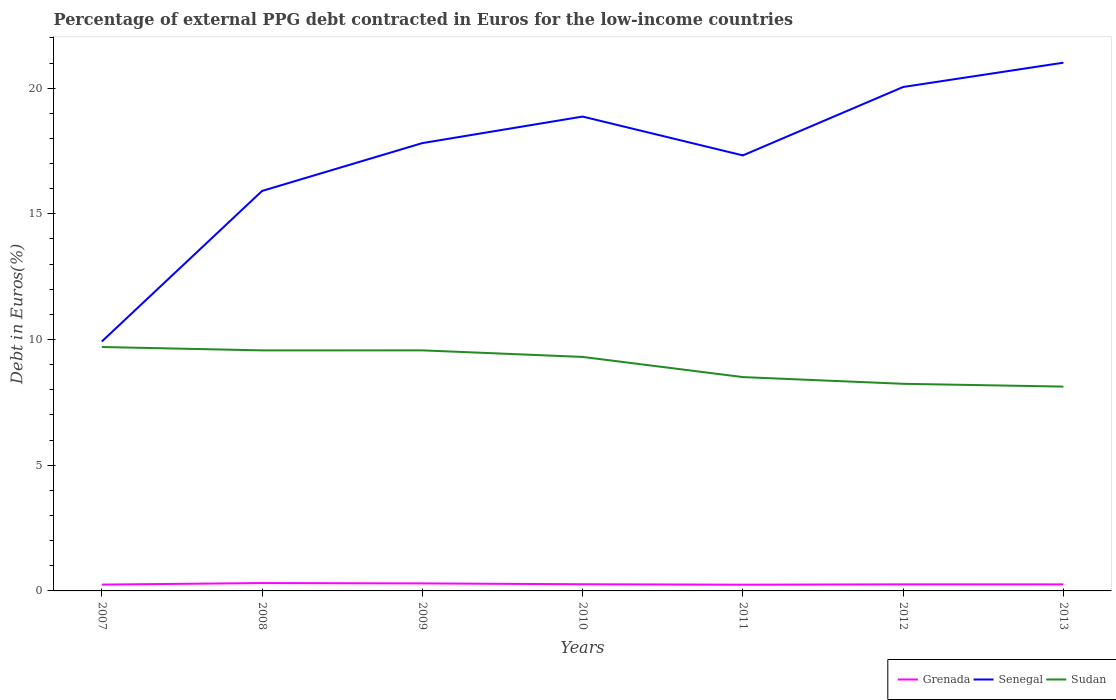Is the number of lines equal to the number of legend labels?
Your answer should be compact. Yes. Across all years, what is the maximum percentage of external PPG debt contracted in Euros in Sudan?
Give a very brief answer. 8.13. In which year was the percentage of external PPG debt contracted in Euros in Senegal maximum?
Give a very brief answer. 2007. What is the total percentage of external PPG debt contracted in Euros in Senegal in the graph?
Provide a succinct answer. -7.4. What is the difference between the highest and the second highest percentage of external PPG debt contracted in Euros in Grenada?
Give a very brief answer. 0.07. What is the difference between the highest and the lowest percentage of external PPG debt contracted in Euros in Senegal?
Provide a short and direct response. 5. How many years are there in the graph?
Your response must be concise. 7. Does the graph contain any zero values?
Make the answer very short. No. How many legend labels are there?
Offer a very short reply. 3. What is the title of the graph?
Make the answer very short. Percentage of external PPG debt contracted in Euros for the low-income countries. Does "Aruba" appear as one of the legend labels in the graph?
Ensure brevity in your answer.  No. What is the label or title of the Y-axis?
Make the answer very short. Debt in Euros(%). What is the Debt in Euros(%) in Grenada in 2007?
Your response must be concise. 0.25. What is the Debt in Euros(%) of Senegal in 2007?
Make the answer very short. 9.92. What is the Debt in Euros(%) of Sudan in 2007?
Your response must be concise. 9.7. What is the Debt in Euros(%) of Grenada in 2008?
Your answer should be compact. 0.31. What is the Debt in Euros(%) of Senegal in 2008?
Your response must be concise. 15.91. What is the Debt in Euros(%) in Sudan in 2008?
Offer a terse response. 9.57. What is the Debt in Euros(%) in Grenada in 2009?
Your response must be concise. 0.3. What is the Debt in Euros(%) of Senegal in 2009?
Offer a very short reply. 17.81. What is the Debt in Euros(%) of Sudan in 2009?
Make the answer very short. 9.57. What is the Debt in Euros(%) in Grenada in 2010?
Provide a short and direct response. 0.27. What is the Debt in Euros(%) in Senegal in 2010?
Keep it short and to the point. 18.87. What is the Debt in Euros(%) in Sudan in 2010?
Give a very brief answer. 9.31. What is the Debt in Euros(%) of Grenada in 2011?
Keep it short and to the point. 0.25. What is the Debt in Euros(%) in Senegal in 2011?
Ensure brevity in your answer.  17.32. What is the Debt in Euros(%) of Sudan in 2011?
Give a very brief answer. 8.51. What is the Debt in Euros(%) in Grenada in 2012?
Your answer should be very brief. 0.26. What is the Debt in Euros(%) of Senegal in 2012?
Keep it short and to the point. 20.05. What is the Debt in Euros(%) in Sudan in 2012?
Offer a very short reply. 8.24. What is the Debt in Euros(%) in Grenada in 2013?
Your answer should be compact. 0.26. What is the Debt in Euros(%) in Senegal in 2013?
Your response must be concise. 21.01. What is the Debt in Euros(%) of Sudan in 2013?
Make the answer very short. 8.13. Across all years, what is the maximum Debt in Euros(%) of Grenada?
Make the answer very short. 0.31. Across all years, what is the maximum Debt in Euros(%) in Senegal?
Give a very brief answer. 21.01. Across all years, what is the maximum Debt in Euros(%) of Sudan?
Offer a very short reply. 9.7. Across all years, what is the minimum Debt in Euros(%) of Grenada?
Your response must be concise. 0.25. Across all years, what is the minimum Debt in Euros(%) in Senegal?
Your answer should be very brief. 9.92. Across all years, what is the minimum Debt in Euros(%) in Sudan?
Keep it short and to the point. 8.13. What is the total Debt in Euros(%) in Grenada in the graph?
Offer a terse response. 1.9. What is the total Debt in Euros(%) in Senegal in the graph?
Provide a succinct answer. 120.9. What is the total Debt in Euros(%) in Sudan in the graph?
Your answer should be compact. 63.02. What is the difference between the Debt in Euros(%) of Grenada in 2007 and that in 2008?
Provide a short and direct response. -0.06. What is the difference between the Debt in Euros(%) of Senegal in 2007 and that in 2008?
Your response must be concise. -5.99. What is the difference between the Debt in Euros(%) of Sudan in 2007 and that in 2008?
Offer a very short reply. 0.13. What is the difference between the Debt in Euros(%) of Grenada in 2007 and that in 2009?
Provide a succinct answer. -0.05. What is the difference between the Debt in Euros(%) of Senegal in 2007 and that in 2009?
Ensure brevity in your answer.  -7.89. What is the difference between the Debt in Euros(%) of Sudan in 2007 and that in 2009?
Keep it short and to the point. 0.13. What is the difference between the Debt in Euros(%) of Grenada in 2007 and that in 2010?
Offer a terse response. -0.01. What is the difference between the Debt in Euros(%) of Senegal in 2007 and that in 2010?
Your answer should be very brief. -8.95. What is the difference between the Debt in Euros(%) of Sudan in 2007 and that in 2010?
Your answer should be compact. 0.39. What is the difference between the Debt in Euros(%) in Grenada in 2007 and that in 2011?
Your answer should be very brief. 0. What is the difference between the Debt in Euros(%) of Senegal in 2007 and that in 2011?
Your answer should be compact. -7.4. What is the difference between the Debt in Euros(%) of Sudan in 2007 and that in 2011?
Offer a terse response. 1.2. What is the difference between the Debt in Euros(%) of Grenada in 2007 and that in 2012?
Offer a terse response. -0.01. What is the difference between the Debt in Euros(%) in Senegal in 2007 and that in 2012?
Your response must be concise. -10.13. What is the difference between the Debt in Euros(%) of Sudan in 2007 and that in 2012?
Your answer should be compact. 1.46. What is the difference between the Debt in Euros(%) of Grenada in 2007 and that in 2013?
Your answer should be compact. -0.01. What is the difference between the Debt in Euros(%) in Senegal in 2007 and that in 2013?
Your answer should be very brief. -11.09. What is the difference between the Debt in Euros(%) in Sudan in 2007 and that in 2013?
Offer a very short reply. 1.58. What is the difference between the Debt in Euros(%) in Grenada in 2008 and that in 2009?
Offer a terse response. 0.01. What is the difference between the Debt in Euros(%) of Senegal in 2008 and that in 2009?
Keep it short and to the point. -1.9. What is the difference between the Debt in Euros(%) in Sudan in 2008 and that in 2009?
Provide a short and direct response. -0. What is the difference between the Debt in Euros(%) of Grenada in 2008 and that in 2010?
Provide a succinct answer. 0.05. What is the difference between the Debt in Euros(%) in Senegal in 2008 and that in 2010?
Offer a very short reply. -2.96. What is the difference between the Debt in Euros(%) in Sudan in 2008 and that in 2010?
Offer a very short reply. 0.26. What is the difference between the Debt in Euros(%) of Grenada in 2008 and that in 2011?
Your response must be concise. 0.07. What is the difference between the Debt in Euros(%) in Senegal in 2008 and that in 2011?
Offer a terse response. -1.41. What is the difference between the Debt in Euros(%) in Sudan in 2008 and that in 2011?
Your answer should be compact. 1.06. What is the difference between the Debt in Euros(%) of Grenada in 2008 and that in 2012?
Your answer should be very brief. 0.05. What is the difference between the Debt in Euros(%) in Senegal in 2008 and that in 2012?
Give a very brief answer. -4.14. What is the difference between the Debt in Euros(%) in Sudan in 2008 and that in 2012?
Ensure brevity in your answer.  1.33. What is the difference between the Debt in Euros(%) in Grenada in 2008 and that in 2013?
Provide a short and direct response. 0.05. What is the difference between the Debt in Euros(%) in Senegal in 2008 and that in 2013?
Give a very brief answer. -5.1. What is the difference between the Debt in Euros(%) of Sudan in 2008 and that in 2013?
Keep it short and to the point. 1.44. What is the difference between the Debt in Euros(%) in Grenada in 2009 and that in 2010?
Give a very brief answer. 0.03. What is the difference between the Debt in Euros(%) of Senegal in 2009 and that in 2010?
Keep it short and to the point. -1.06. What is the difference between the Debt in Euros(%) in Sudan in 2009 and that in 2010?
Provide a short and direct response. 0.26. What is the difference between the Debt in Euros(%) in Grenada in 2009 and that in 2011?
Ensure brevity in your answer.  0.05. What is the difference between the Debt in Euros(%) of Senegal in 2009 and that in 2011?
Offer a terse response. 0.49. What is the difference between the Debt in Euros(%) in Sudan in 2009 and that in 2011?
Provide a succinct answer. 1.06. What is the difference between the Debt in Euros(%) in Grenada in 2009 and that in 2012?
Make the answer very short. 0.04. What is the difference between the Debt in Euros(%) of Senegal in 2009 and that in 2012?
Your response must be concise. -2.23. What is the difference between the Debt in Euros(%) in Sudan in 2009 and that in 2012?
Make the answer very short. 1.33. What is the difference between the Debt in Euros(%) of Grenada in 2009 and that in 2013?
Provide a short and direct response. 0.04. What is the difference between the Debt in Euros(%) of Senegal in 2009 and that in 2013?
Your response must be concise. -3.2. What is the difference between the Debt in Euros(%) of Sudan in 2009 and that in 2013?
Make the answer very short. 1.44. What is the difference between the Debt in Euros(%) of Grenada in 2010 and that in 2011?
Your answer should be compact. 0.02. What is the difference between the Debt in Euros(%) of Senegal in 2010 and that in 2011?
Your response must be concise. 1.55. What is the difference between the Debt in Euros(%) in Sudan in 2010 and that in 2011?
Offer a terse response. 0.8. What is the difference between the Debt in Euros(%) in Grenada in 2010 and that in 2012?
Offer a very short reply. 0. What is the difference between the Debt in Euros(%) in Senegal in 2010 and that in 2012?
Make the answer very short. -1.18. What is the difference between the Debt in Euros(%) of Sudan in 2010 and that in 2012?
Make the answer very short. 1.07. What is the difference between the Debt in Euros(%) in Grenada in 2010 and that in 2013?
Ensure brevity in your answer.  0.01. What is the difference between the Debt in Euros(%) of Senegal in 2010 and that in 2013?
Your response must be concise. -2.14. What is the difference between the Debt in Euros(%) in Sudan in 2010 and that in 2013?
Provide a succinct answer. 1.18. What is the difference between the Debt in Euros(%) of Grenada in 2011 and that in 2012?
Provide a succinct answer. -0.01. What is the difference between the Debt in Euros(%) of Senegal in 2011 and that in 2012?
Offer a very short reply. -2.72. What is the difference between the Debt in Euros(%) in Sudan in 2011 and that in 2012?
Your answer should be very brief. 0.27. What is the difference between the Debt in Euros(%) in Grenada in 2011 and that in 2013?
Make the answer very short. -0.01. What is the difference between the Debt in Euros(%) of Senegal in 2011 and that in 2013?
Ensure brevity in your answer.  -3.69. What is the difference between the Debt in Euros(%) of Sudan in 2011 and that in 2013?
Keep it short and to the point. 0.38. What is the difference between the Debt in Euros(%) in Grenada in 2012 and that in 2013?
Your response must be concise. 0. What is the difference between the Debt in Euros(%) of Senegal in 2012 and that in 2013?
Keep it short and to the point. -0.97. What is the difference between the Debt in Euros(%) of Sudan in 2012 and that in 2013?
Offer a very short reply. 0.11. What is the difference between the Debt in Euros(%) of Grenada in 2007 and the Debt in Euros(%) of Senegal in 2008?
Your response must be concise. -15.66. What is the difference between the Debt in Euros(%) of Grenada in 2007 and the Debt in Euros(%) of Sudan in 2008?
Keep it short and to the point. -9.32. What is the difference between the Debt in Euros(%) in Senegal in 2007 and the Debt in Euros(%) in Sudan in 2008?
Provide a succinct answer. 0.35. What is the difference between the Debt in Euros(%) of Grenada in 2007 and the Debt in Euros(%) of Senegal in 2009?
Make the answer very short. -17.56. What is the difference between the Debt in Euros(%) of Grenada in 2007 and the Debt in Euros(%) of Sudan in 2009?
Give a very brief answer. -9.32. What is the difference between the Debt in Euros(%) of Senegal in 2007 and the Debt in Euros(%) of Sudan in 2009?
Your response must be concise. 0.35. What is the difference between the Debt in Euros(%) of Grenada in 2007 and the Debt in Euros(%) of Senegal in 2010?
Offer a terse response. -18.62. What is the difference between the Debt in Euros(%) in Grenada in 2007 and the Debt in Euros(%) in Sudan in 2010?
Ensure brevity in your answer.  -9.06. What is the difference between the Debt in Euros(%) of Senegal in 2007 and the Debt in Euros(%) of Sudan in 2010?
Your answer should be compact. 0.61. What is the difference between the Debt in Euros(%) of Grenada in 2007 and the Debt in Euros(%) of Senegal in 2011?
Ensure brevity in your answer.  -17.07. What is the difference between the Debt in Euros(%) in Grenada in 2007 and the Debt in Euros(%) in Sudan in 2011?
Your answer should be very brief. -8.25. What is the difference between the Debt in Euros(%) of Senegal in 2007 and the Debt in Euros(%) of Sudan in 2011?
Offer a very short reply. 1.41. What is the difference between the Debt in Euros(%) of Grenada in 2007 and the Debt in Euros(%) of Senegal in 2012?
Your response must be concise. -19.79. What is the difference between the Debt in Euros(%) of Grenada in 2007 and the Debt in Euros(%) of Sudan in 2012?
Keep it short and to the point. -7.99. What is the difference between the Debt in Euros(%) of Senegal in 2007 and the Debt in Euros(%) of Sudan in 2012?
Your response must be concise. 1.68. What is the difference between the Debt in Euros(%) of Grenada in 2007 and the Debt in Euros(%) of Senegal in 2013?
Offer a terse response. -20.76. What is the difference between the Debt in Euros(%) of Grenada in 2007 and the Debt in Euros(%) of Sudan in 2013?
Offer a very short reply. -7.88. What is the difference between the Debt in Euros(%) of Senegal in 2007 and the Debt in Euros(%) of Sudan in 2013?
Give a very brief answer. 1.79. What is the difference between the Debt in Euros(%) in Grenada in 2008 and the Debt in Euros(%) in Senegal in 2009?
Make the answer very short. -17.5. What is the difference between the Debt in Euros(%) of Grenada in 2008 and the Debt in Euros(%) of Sudan in 2009?
Make the answer very short. -9.26. What is the difference between the Debt in Euros(%) in Senegal in 2008 and the Debt in Euros(%) in Sudan in 2009?
Provide a succinct answer. 6.34. What is the difference between the Debt in Euros(%) of Grenada in 2008 and the Debt in Euros(%) of Senegal in 2010?
Your response must be concise. -18.56. What is the difference between the Debt in Euros(%) in Grenada in 2008 and the Debt in Euros(%) in Sudan in 2010?
Make the answer very short. -9. What is the difference between the Debt in Euros(%) of Senegal in 2008 and the Debt in Euros(%) of Sudan in 2010?
Your answer should be very brief. 6.6. What is the difference between the Debt in Euros(%) of Grenada in 2008 and the Debt in Euros(%) of Senegal in 2011?
Your response must be concise. -17.01. What is the difference between the Debt in Euros(%) in Grenada in 2008 and the Debt in Euros(%) in Sudan in 2011?
Ensure brevity in your answer.  -8.19. What is the difference between the Debt in Euros(%) in Senegal in 2008 and the Debt in Euros(%) in Sudan in 2011?
Provide a short and direct response. 7.4. What is the difference between the Debt in Euros(%) in Grenada in 2008 and the Debt in Euros(%) in Senegal in 2012?
Offer a very short reply. -19.73. What is the difference between the Debt in Euros(%) in Grenada in 2008 and the Debt in Euros(%) in Sudan in 2012?
Your answer should be compact. -7.93. What is the difference between the Debt in Euros(%) in Senegal in 2008 and the Debt in Euros(%) in Sudan in 2012?
Give a very brief answer. 7.67. What is the difference between the Debt in Euros(%) in Grenada in 2008 and the Debt in Euros(%) in Senegal in 2013?
Make the answer very short. -20.7. What is the difference between the Debt in Euros(%) of Grenada in 2008 and the Debt in Euros(%) of Sudan in 2013?
Make the answer very short. -7.82. What is the difference between the Debt in Euros(%) of Senegal in 2008 and the Debt in Euros(%) of Sudan in 2013?
Ensure brevity in your answer.  7.78. What is the difference between the Debt in Euros(%) in Grenada in 2009 and the Debt in Euros(%) in Senegal in 2010?
Ensure brevity in your answer.  -18.57. What is the difference between the Debt in Euros(%) in Grenada in 2009 and the Debt in Euros(%) in Sudan in 2010?
Ensure brevity in your answer.  -9.01. What is the difference between the Debt in Euros(%) of Senegal in 2009 and the Debt in Euros(%) of Sudan in 2010?
Offer a very short reply. 8.51. What is the difference between the Debt in Euros(%) in Grenada in 2009 and the Debt in Euros(%) in Senegal in 2011?
Provide a succinct answer. -17.03. What is the difference between the Debt in Euros(%) in Grenada in 2009 and the Debt in Euros(%) in Sudan in 2011?
Offer a very short reply. -8.21. What is the difference between the Debt in Euros(%) of Senegal in 2009 and the Debt in Euros(%) of Sudan in 2011?
Offer a terse response. 9.31. What is the difference between the Debt in Euros(%) in Grenada in 2009 and the Debt in Euros(%) in Senegal in 2012?
Your answer should be compact. -19.75. What is the difference between the Debt in Euros(%) of Grenada in 2009 and the Debt in Euros(%) of Sudan in 2012?
Keep it short and to the point. -7.94. What is the difference between the Debt in Euros(%) of Senegal in 2009 and the Debt in Euros(%) of Sudan in 2012?
Your response must be concise. 9.57. What is the difference between the Debt in Euros(%) in Grenada in 2009 and the Debt in Euros(%) in Senegal in 2013?
Offer a terse response. -20.71. What is the difference between the Debt in Euros(%) of Grenada in 2009 and the Debt in Euros(%) of Sudan in 2013?
Provide a short and direct response. -7.83. What is the difference between the Debt in Euros(%) in Senegal in 2009 and the Debt in Euros(%) in Sudan in 2013?
Provide a succinct answer. 9.69. What is the difference between the Debt in Euros(%) in Grenada in 2010 and the Debt in Euros(%) in Senegal in 2011?
Keep it short and to the point. -17.06. What is the difference between the Debt in Euros(%) of Grenada in 2010 and the Debt in Euros(%) of Sudan in 2011?
Provide a succinct answer. -8.24. What is the difference between the Debt in Euros(%) of Senegal in 2010 and the Debt in Euros(%) of Sudan in 2011?
Make the answer very short. 10.36. What is the difference between the Debt in Euros(%) of Grenada in 2010 and the Debt in Euros(%) of Senegal in 2012?
Your answer should be very brief. -19.78. What is the difference between the Debt in Euros(%) of Grenada in 2010 and the Debt in Euros(%) of Sudan in 2012?
Provide a short and direct response. -7.97. What is the difference between the Debt in Euros(%) of Senegal in 2010 and the Debt in Euros(%) of Sudan in 2012?
Your answer should be very brief. 10.63. What is the difference between the Debt in Euros(%) in Grenada in 2010 and the Debt in Euros(%) in Senegal in 2013?
Ensure brevity in your answer.  -20.75. What is the difference between the Debt in Euros(%) in Grenada in 2010 and the Debt in Euros(%) in Sudan in 2013?
Offer a very short reply. -7.86. What is the difference between the Debt in Euros(%) in Senegal in 2010 and the Debt in Euros(%) in Sudan in 2013?
Provide a succinct answer. 10.74. What is the difference between the Debt in Euros(%) of Grenada in 2011 and the Debt in Euros(%) of Senegal in 2012?
Give a very brief answer. -19.8. What is the difference between the Debt in Euros(%) of Grenada in 2011 and the Debt in Euros(%) of Sudan in 2012?
Give a very brief answer. -7.99. What is the difference between the Debt in Euros(%) of Senegal in 2011 and the Debt in Euros(%) of Sudan in 2012?
Your response must be concise. 9.08. What is the difference between the Debt in Euros(%) in Grenada in 2011 and the Debt in Euros(%) in Senegal in 2013?
Make the answer very short. -20.77. What is the difference between the Debt in Euros(%) of Grenada in 2011 and the Debt in Euros(%) of Sudan in 2013?
Give a very brief answer. -7.88. What is the difference between the Debt in Euros(%) in Senegal in 2011 and the Debt in Euros(%) in Sudan in 2013?
Give a very brief answer. 9.2. What is the difference between the Debt in Euros(%) in Grenada in 2012 and the Debt in Euros(%) in Senegal in 2013?
Your answer should be very brief. -20.75. What is the difference between the Debt in Euros(%) in Grenada in 2012 and the Debt in Euros(%) in Sudan in 2013?
Give a very brief answer. -7.87. What is the difference between the Debt in Euros(%) of Senegal in 2012 and the Debt in Euros(%) of Sudan in 2013?
Your response must be concise. 11.92. What is the average Debt in Euros(%) in Grenada per year?
Make the answer very short. 0.27. What is the average Debt in Euros(%) in Senegal per year?
Your response must be concise. 17.27. What is the average Debt in Euros(%) in Sudan per year?
Give a very brief answer. 9. In the year 2007, what is the difference between the Debt in Euros(%) of Grenada and Debt in Euros(%) of Senegal?
Make the answer very short. -9.67. In the year 2007, what is the difference between the Debt in Euros(%) in Grenada and Debt in Euros(%) in Sudan?
Provide a short and direct response. -9.45. In the year 2007, what is the difference between the Debt in Euros(%) of Senegal and Debt in Euros(%) of Sudan?
Provide a succinct answer. 0.22. In the year 2008, what is the difference between the Debt in Euros(%) in Grenada and Debt in Euros(%) in Senegal?
Your answer should be very brief. -15.6. In the year 2008, what is the difference between the Debt in Euros(%) in Grenada and Debt in Euros(%) in Sudan?
Ensure brevity in your answer.  -9.26. In the year 2008, what is the difference between the Debt in Euros(%) of Senegal and Debt in Euros(%) of Sudan?
Offer a terse response. 6.34. In the year 2009, what is the difference between the Debt in Euros(%) in Grenada and Debt in Euros(%) in Senegal?
Make the answer very short. -17.52. In the year 2009, what is the difference between the Debt in Euros(%) of Grenada and Debt in Euros(%) of Sudan?
Give a very brief answer. -9.27. In the year 2009, what is the difference between the Debt in Euros(%) in Senegal and Debt in Euros(%) in Sudan?
Ensure brevity in your answer.  8.24. In the year 2010, what is the difference between the Debt in Euros(%) of Grenada and Debt in Euros(%) of Senegal?
Your answer should be compact. -18.6. In the year 2010, what is the difference between the Debt in Euros(%) in Grenada and Debt in Euros(%) in Sudan?
Ensure brevity in your answer.  -9.04. In the year 2010, what is the difference between the Debt in Euros(%) in Senegal and Debt in Euros(%) in Sudan?
Make the answer very short. 9.56. In the year 2011, what is the difference between the Debt in Euros(%) in Grenada and Debt in Euros(%) in Senegal?
Your response must be concise. -17.08. In the year 2011, what is the difference between the Debt in Euros(%) of Grenada and Debt in Euros(%) of Sudan?
Your answer should be very brief. -8.26. In the year 2011, what is the difference between the Debt in Euros(%) of Senegal and Debt in Euros(%) of Sudan?
Your answer should be compact. 8.82. In the year 2012, what is the difference between the Debt in Euros(%) of Grenada and Debt in Euros(%) of Senegal?
Provide a short and direct response. -19.78. In the year 2012, what is the difference between the Debt in Euros(%) of Grenada and Debt in Euros(%) of Sudan?
Your answer should be compact. -7.98. In the year 2012, what is the difference between the Debt in Euros(%) in Senegal and Debt in Euros(%) in Sudan?
Give a very brief answer. 11.81. In the year 2013, what is the difference between the Debt in Euros(%) of Grenada and Debt in Euros(%) of Senegal?
Make the answer very short. -20.75. In the year 2013, what is the difference between the Debt in Euros(%) of Grenada and Debt in Euros(%) of Sudan?
Give a very brief answer. -7.87. In the year 2013, what is the difference between the Debt in Euros(%) of Senegal and Debt in Euros(%) of Sudan?
Provide a succinct answer. 12.89. What is the ratio of the Debt in Euros(%) in Grenada in 2007 to that in 2008?
Your answer should be very brief. 0.8. What is the ratio of the Debt in Euros(%) in Senegal in 2007 to that in 2008?
Your answer should be very brief. 0.62. What is the ratio of the Debt in Euros(%) in Sudan in 2007 to that in 2008?
Provide a succinct answer. 1.01. What is the ratio of the Debt in Euros(%) in Grenada in 2007 to that in 2009?
Offer a terse response. 0.84. What is the ratio of the Debt in Euros(%) in Senegal in 2007 to that in 2009?
Give a very brief answer. 0.56. What is the ratio of the Debt in Euros(%) in Sudan in 2007 to that in 2009?
Make the answer very short. 1.01. What is the ratio of the Debt in Euros(%) of Grenada in 2007 to that in 2010?
Keep it short and to the point. 0.95. What is the ratio of the Debt in Euros(%) in Senegal in 2007 to that in 2010?
Your answer should be compact. 0.53. What is the ratio of the Debt in Euros(%) in Sudan in 2007 to that in 2010?
Offer a terse response. 1.04. What is the ratio of the Debt in Euros(%) of Grenada in 2007 to that in 2011?
Offer a terse response. 1.02. What is the ratio of the Debt in Euros(%) of Senegal in 2007 to that in 2011?
Offer a very short reply. 0.57. What is the ratio of the Debt in Euros(%) of Sudan in 2007 to that in 2011?
Provide a succinct answer. 1.14. What is the ratio of the Debt in Euros(%) in Grenada in 2007 to that in 2012?
Offer a very short reply. 0.96. What is the ratio of the Debt in Euros(%) in Senegal in 2007 to that in 2012?
Offer a very short reply. 0.49. What is the ratio of the Debt in Euros(%) of Sudan in 2007 to that in 2012?
Make the answer very short. 1.18. What is the ratio of the Debt in Euros(%) of Grenada in 2007 to that in 2013?
Your answer should be very brief. 0.97. What is the ratio of the Debt in Euros(%) in Senegal in 2007 to that in 2013?
Provide a short and direct response. 0.47. What is the ratio of the Debt in Euros(%) of Sudan in 2007 to that in 2013?
Offer a very short reply. 1.19. What is the ratio of the Debt in Euros(%) in Grenada in 2008 to that in 2009?
Your answer should be very brief. 1.05. What is the ratio of the Debt in Euros(%) of Senegal in 2008 to that in 2009?
Make the answer very short. 0.89. What is the ratio of the Debt in Euros(%) of Grenada in 2008 to that in 2010?
Your answer should be compact. 1.18. What is the ratio of the Debt in Euros(%) of Senegal in 2008 to that in 2010?
Your answer should be very brief. 0.84. What is the ratio of the Debt in Euros(%) in Sudan in 2008 to that in 2010?
Offer a very short reply. 1.03. What is the ratio of the Debt in Euros(%) of Grenada in 2008 to that in 2011?
Keep it short and to the point. 1.26. What is the ratio of the Debt in Euros(%) in Senegal in 2008 to that in 2011?
Offer a very short reply. 0.92. What is the ratio of the Debt in Euros(%) of Sudan in 2008 to that in 2011?
Make the answer very short. 1.12. What is the ratio of the Debt in Euros(%) in Grenada in 2008 to that in 2012?
Your answer should be very brief. 1.2. What is the ratio of the Debt in Euros(%) in Senegal in 2008 to that in 2012?
Give a very brief answer. 0.79. What is the ratio of the Debt in Euros(%) of Sudan in 2008 to that in 2012?
Offer a very short reply. 1.16. What is the ratio of the Debt in Euros(%) in Grenada in 2008 to that in 2013?
Offer a very short reply. 1.2. What is the ratio of the Debt in Euros(%) in Senegal in 2008 to that in 2013?
Offer a very short reply. 0.76. What is the ratio of the Debt in Euros(%) in Sudan in 2008 to that in 2013?
Offer a terse response. 1.18. What is the ratio of the Debt in Euros(%) of Grenada in 2009 to that in 2010?
Offer a very short reply. 1.13. What is the ratio of the Debt in Euros(%) of Senegal in 2009 to that in 2010?
Provide a short and direct response. 0.94. What is the ratio of the Debt in Euros(%) of Sudan in 2009 to that in 2010?
Your response must be concise. 1.03. What is the ratio of the Debt in Euros(%) of Grenada in 2009 to that in 2011?
Provide a short and direct response. 1.21. What is the ratio of the Debt in Euros(%) in Senegal in 2009 to that in 2011?
Your response must be concise. 1.03. What is the ratio of the Debt in Euros(%) in Grenada in 2009 to that in 2012?
Keep it short and to the point. 1.14. What is the ratio of the Debt in Euros(%) in Senegal in 2009 to that in 2012?
Keep it short and to the point. 0.89. What is the ratio of the Debt in Euros(%) in Sudan in 2009 to that in 2012?
Your response must be concise. 1.16. What is the ratio of the Debt in Euros(%) in Grenada in 2009 to that in 2013?
Your response must be concise. 1.15. What is the ratio of the Debt in Euros(%) of Senegal in 2009 to that in 2013?
Provide a succinct answer. 0.85. What is the ratio of the Debt in Euros(%) in Sudan in 2009 to that in 2013?
Ensure brevity in your answer.  1.18. What is the ratio of the Debt in Euros(%) in Grenada in 2010 to that in 2011?
Offer a terse response. 1.07. What is the ratio of the Debt in Euros(%) of Senegal in 2010 to that in 2011?
Offer a very short reply. 1.09. What is the ratio of the Debt in Euros(%) in Sudan in 2010 to that in 2011?
Ensure brevity in your answer.  1.09. What is the ratio of the Debt in Euros(%) of Grenada in 2010 to that in 2012?
Give a very brief answer. 1.02. What is the ratio of the Debt in Euros(%) of Senegal in 2010 to that in 2012?
Your response must be concise. 0.94. What is the ratio of the Debt in Euros(%) of Sudan in 2010 to that in 2012?
Give a very brief answer. 1.13. What is the ratio of the Debt in Euros(%) in Grenada in 2010 to that in 2013?
Your response must be concise. 1.02. What is the ratio of the Debt in Euros(%) of Senegal in 2010 to that in 2013?
Offer a very short reply. 0.9. What is the ratio of the Debt in Euros(%) of Sudan in 2010 to that in 2013?
Keep it short and to the point. 1.15. What is the ratio of the Debt in Euros(%) in Grenada in 2011 to that in 2012?
Keep it short and to the point. 0.95. What is the ratio of the Debt in Euros(%) of Senegal in 2011 to that in 2012?
Your response must be concise. 0.86. What is the ratio of the Debt in Euros(%) of Sudan in 2011 to that in 2012?
Your answer should be very brief. 1.03. What is the ratio of the Debt in Euros(%) in Grenada in 2011 to that in 2013?
Provide a short and direct response. 0.95. What is the ratio of the Debt in Euros(%) in Senegal in 2011 to that in 2013?
Keep it short and to the point. 0.82. What is the ratio of the Debt in Euros(%) in Sudan in 2011 to that in 2013?
Offer a very short reply. 1.05. What is the ratio of the Debt in Euros(%) of Senegal in 2012 to that in 2013?
Provide a succinct answer. 0.95. What is the ratio of the Debt in Euros(%) of Sudan in 2012 to that in 2013?
Offer a terse response. 1.01. What is the difference between the highest and the second highest Debt in Euros(%) of Grenada?
Provide a succinct answer. 0.01. What is the difference between the highest and the second highest Debt in Euros(%) in Sudan?
Offer a terse response. 0.13. What is the difference between the highest and the lowest Debt in Euros(%) of Grenada?
Your answer should be very brief. 0.07. What is the difference between the highest and the lowest Debt in Euros(%) in Senegal?
Offer a terse response. 11.09. What is the difference between the highest and the lowest Debt in Euros(%) in Sudan?
Your response must be concise. 1.58. 